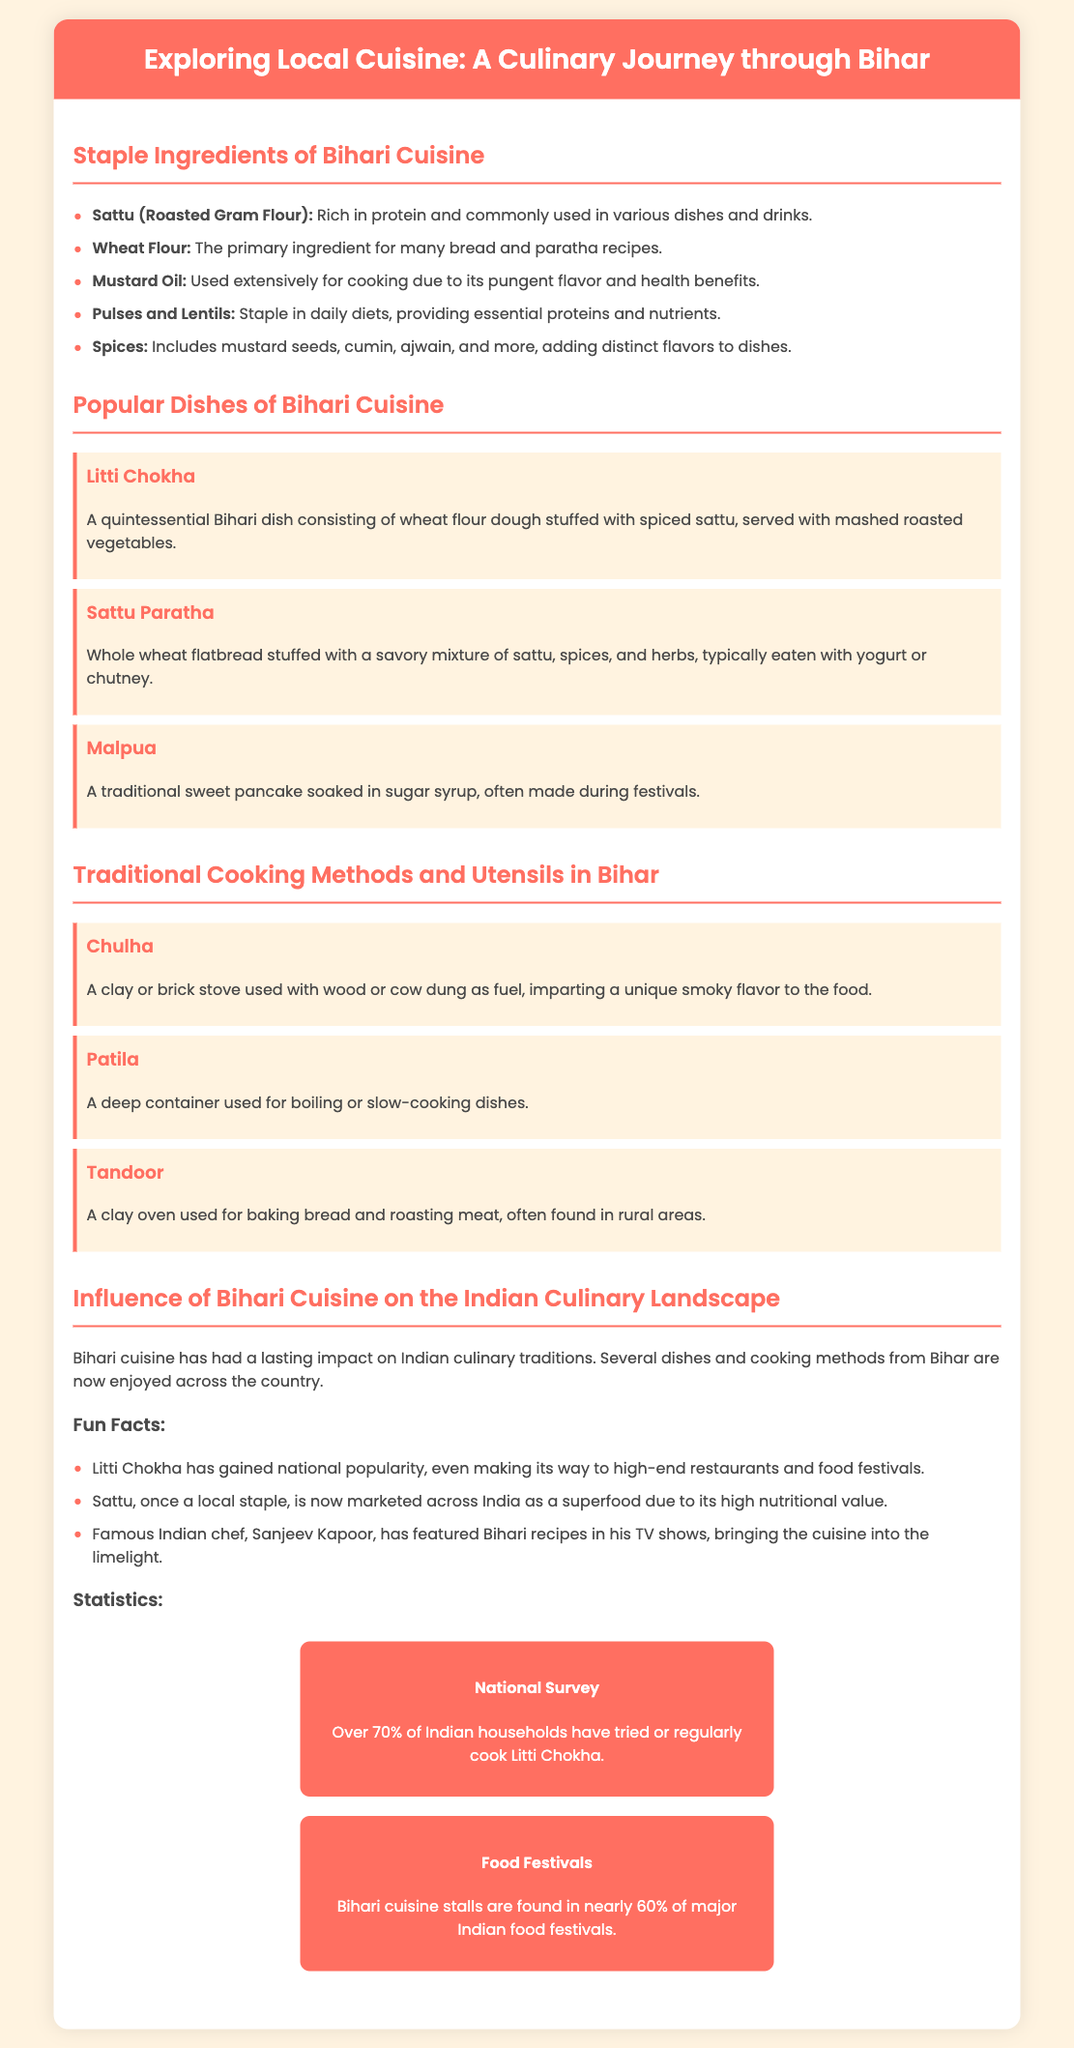What is the title of the presentation? The title of the presentation is prominently displayed at the top of the document.
Answer: Exploring Local Cuisine: A Culinary Journey through Bihar What is Sattu commonly used for? Sattu is mentioned as a rich source of protein used in various dishes and drinks in the document.
Answer: Dishes and drinks What are the three popular dishes highlighted in Bihari cuisine? The presentation lists specific popular dishes in one of the slides.
Answer: Litti Chokha, Sattu Paratha, Malpua What is a Chulha? A Chulha is described in the presentation as a type of cooking stove that uses wood or cow dung.
Answer: Cooking stove What percentage of Indian households have tried or regularly cook Litti Chokha? The document provides a specific statistic regarding Litti Chokha in the "Statistics" section.
Answer: Over 70% How does Bihari cuisine influence other regions? The document discusses the broader impact of Bihari cuisine on Indian culinary traditions.
Answer: Lasting impact Which cooking method uses a clay oven? The presentation lists traditional cooking methods, one of which is a clay oven.
Answer: Tandoor What is the main ingredient in Sattu Paratha? The document specifies what Sattu Paratha is made from in the description.
Answer: Sattu 